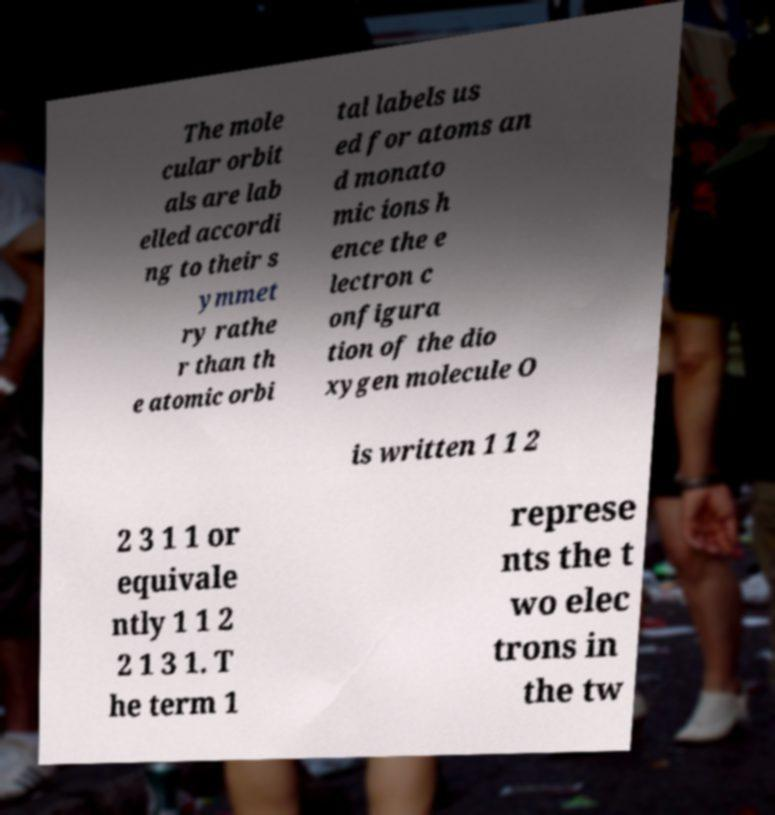Could you extract and type out the text from this image? The mole cular orbit als are lab elled accordi ng to their s ymmet ry rathe r than th e atomic orbi tal labels us ed for atoms an d monato mic ions h ence the e lectron c onfigura tion of the dio xygen molecule O is written 1 1 2 2 3 1 1 or equivale ntly 1 1 2 2 1 3 1. T he term 1 represe nts the t wo elec trons in the tw 